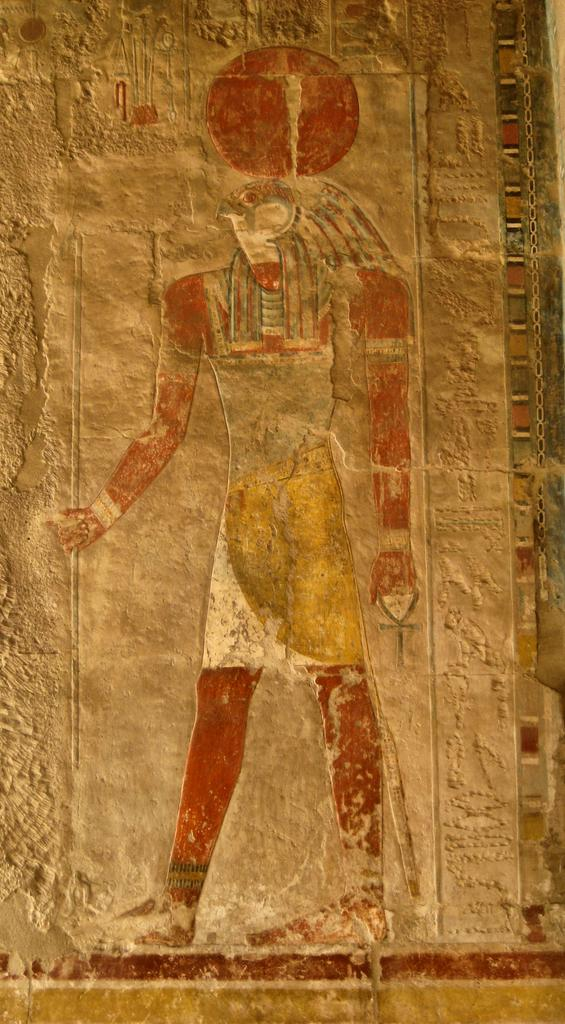What type of artwork is featured in the image? There is a Horus artwork in the image. Where is the artwork positioned in the image? The artwork is located in the center of the image. How long did the journey to the airport take in the image? There is no mention of an airport or journey in the image, as it solely features a Horus artwork. 